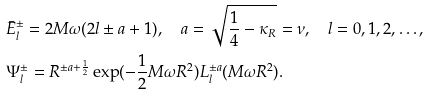Convert formula to latex. <formula><loc_0><loc_0><loc_500><loc_500>& \bar { E } ^ { \pm } _ { l } = 2 M \omega ( 2 l \pm a + 1 ) , \quad a = \sqrt { \frac { 1 } { 4 } - \kappa _ { R } } = \nu , \quad l = 0 , 1 , 2 , \dots , \\ & \Psi _ { l } ^ { \pm } = R ^ { \pm a + \frac { 1 } { 2 } } \exp ( - \frac { 1 } { 2 } M \omega R ^ { 2 } ) L _ { l } ^ { \pm a } ( M \omega R ^ { 2 } ) . \\</formula> 